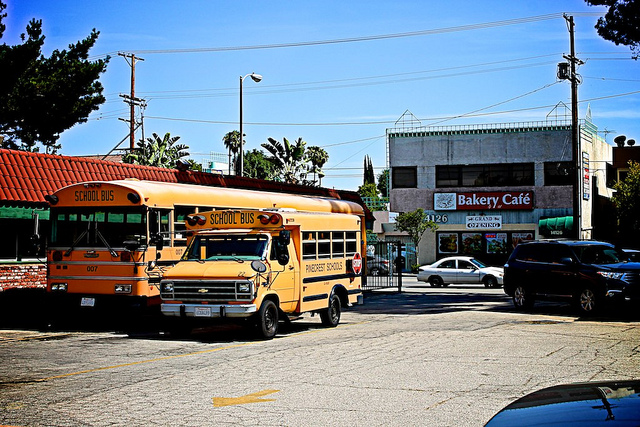<image>What is the number on the nearest bus? It is unclear what the number on the nearest bus is. It could be '2', '007', '5', '0', or '22'. What is the number on the nearest bus? I don't know what is the number on the nearest bus. It can be seen as '2', '007', '5', '0', '22'. 